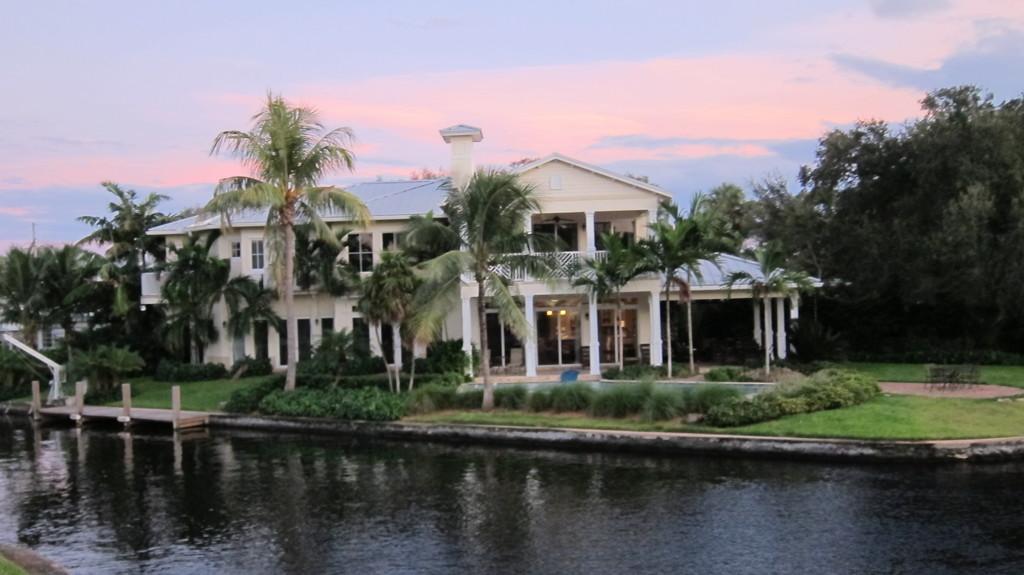Can you describe this image briefly? There is water, grass, trees and a white building. 